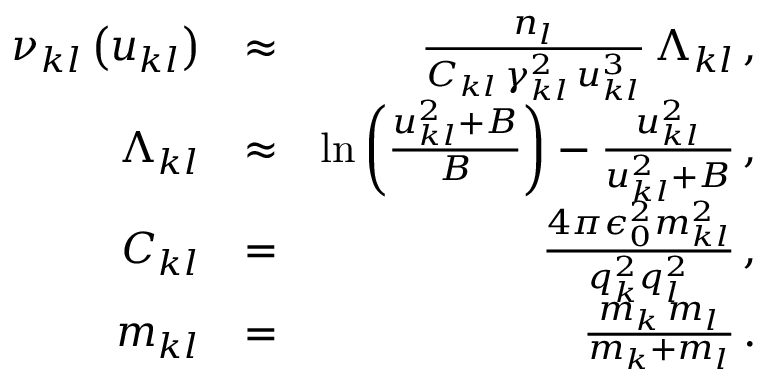Convert formula to latex. <formula><loc_0><loc_0><loc_500><loc_500>\begin{array} { r l r } { \nu _ { k l } \left ( u _ { k l } \right ) } & { \approx } & { \frac { n _ { l } } { C _ { k l } \, \gamma _ { k l } ^ { 2 } \, u _ { k l } ^ { 3 } } \, \Lambda _ { k l } \, , } \\ { \Lambda _ { k l } } & { \approx } & { \ln \left ( \frac { u _ { k l } ^ { 2 } + B } { B } \right ) - \frac { u _ { k l } ^ { 2 } } { u _ { k l } ^ { 2 } + B } \, , } \\ { C _ { k l } } & { = } & { \frac { 4 \pi \epsilon _ { 0 } ^ { 2 } m _ { k l } ^ { 2 } } { q _ { k } ^ { 2 } q _ { l } ^ { 2 } } \, , } \\ { m _ { k l } } & { = } & { \frac { m _ { k } \, m _ { l } } { m _ { k } + m _ { l } } \, . } \end{array}</formula> 